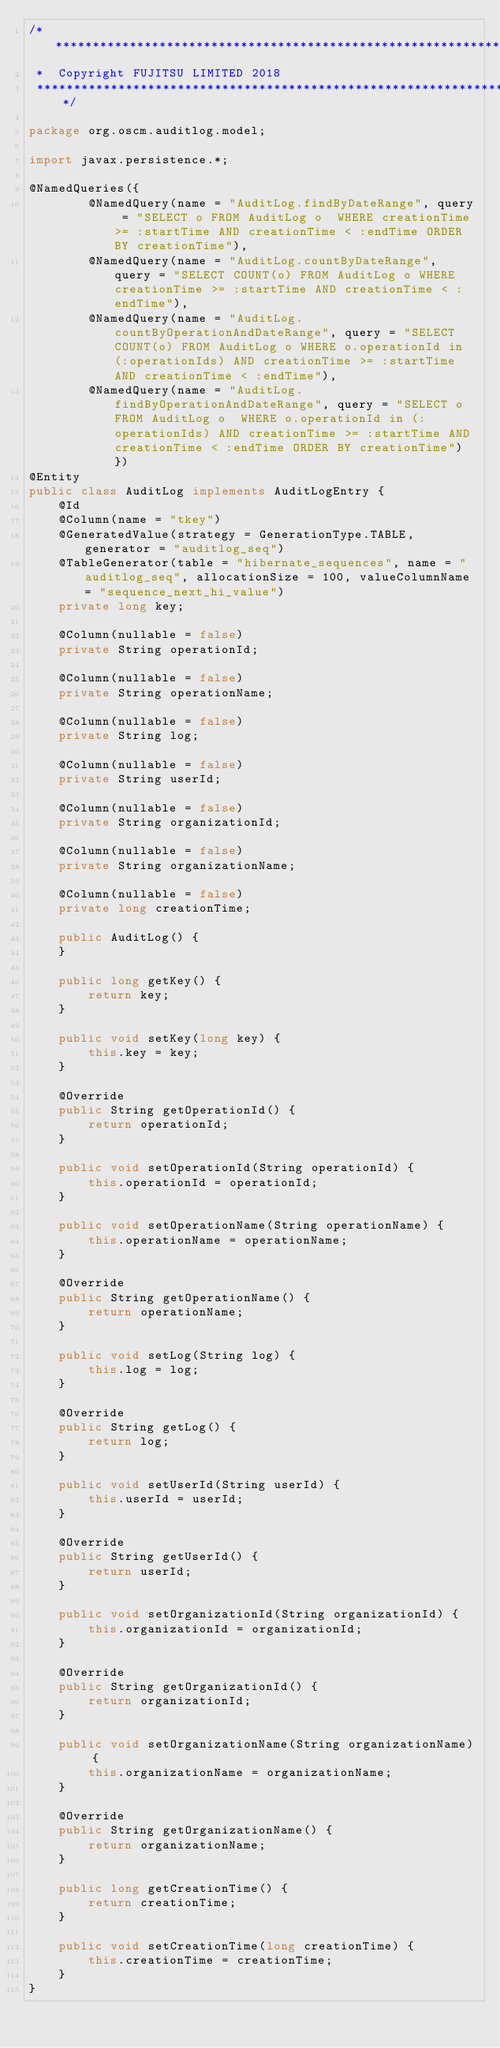Convert code to text. <code><loc_0><loc_0><loc_500><loc_500><_Java_>/*******************************************************************************
 *  Copyright FUJITSU LIMITED 2018
 *******************************************************************************/

package org.oscm.auditlog.model;

import javax.persistence.*;

@NamedQueries({
        @NamedQuery(name = "AuditLog.findByDateRange", query = "SELECT o FROM AuditLog o  WHERE creationTime >= :startTime AND creationTime < :endTime ORDER BY creationTime"),
        @NamedQuery(name = "AuditLog.countByDateRange", query = "SELECT COUNT(o) FROM AuditLog o WHERE creationTime >= :startTime AND creationTime < :endTime"),
        @NamedQuery(name = "AuditLog.countByOperationAndDateRange", query = "SELECT COUNT(o) FROM AuditLog o WHERE o.operationId in (:operationIds) AND creationTime >= :startTime AND creationTime < :endTime"),
        @NamedQuery(name = "AuditLog.findByOperationAndDateRange", query = "SELECT o FROM AuditLog o  WHERE o.operationId in (:operationIds) AND creationTime >= :startTime AND creationTime < :endTime ORDER BY creationTime") })
@Entity
public class AuditLog implements AuditLogEntry {
    @Id
    @Column(name = "tkey")
    @GeneratedValue(strategy = GenerationType.TABLE, generator = "auditlog_seq")
    @TableGenerator(table = "hibernate_sequences", name = "auditlog_seq", allocationSize = 100, valueColumnName = "sequence_next_hi_value")
    private long key;

    @Column(nullable = false)
    private String operationId;

    @Column(nullable = false)
    private String operationName;

    @Column(nullable = false)
    private String log;

    @Column(nullable = false)
    private String userId;

    @Column(nullable = false)
    private String organizationId;

    @Column(nullable = false)
    private String organizationName;

    @Column(nullable = false)
    private long creationTime;

    public AuditLog() {
    }

    public long getKey() {
        return key;
    }

    public void setKey(long key) {
        this.key = key;
    }

    @Override
    public String getOperationId() {
        return operationId;
    }

    public void setOperationId(String operationId) {
        this.operationId = operationId;
    }

    public void setOperationName(String operationName) {
        this.operationName = operationName;
    }

    @Override
    public String getOperationName() {
        return operationName;
    }

    public void setLog(String log) {
        this.log = log;
    }

    @Override
    public String getLog() {
        return log;
    }

    public void setUserId(String userId) {
        this.userId = userId;
    }

    @Override
    public String getUserId() {
        return userId;
    }

    public void setOrganizationId(String organizationId) {
        this.organizationId = organizationId;
    }

    @Override
    public String getOrganizationId() {
        return organizationId;
    }

    public void setOrganizationName(String organizationName) {
        this.organizationName = organizationName;
    }

    @Override
    public String getOrganizationName() {
        return organizationName;
    }

    public long getCreationTime() {
        return creationTime;
    }

    public void setCreationTime(long creationTime) {
        this.creationTime = creationTime;
    }
}
</code> 